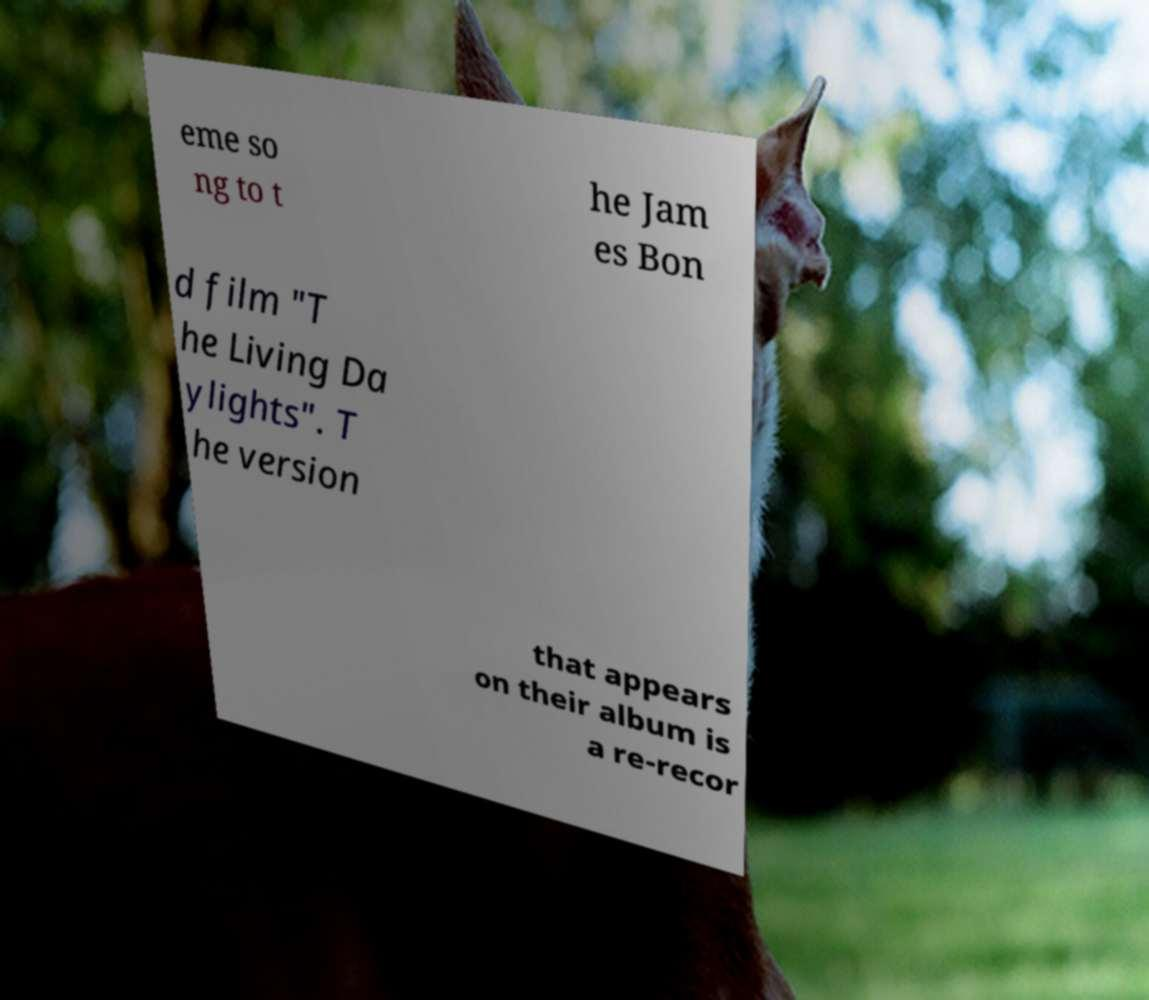Could you assist in decoding the text presented in this image and type it out clearly? eme so ng to t he Jam es Bon d film "T he Living Da ylights". T he version that appears on their album is a re-recor 